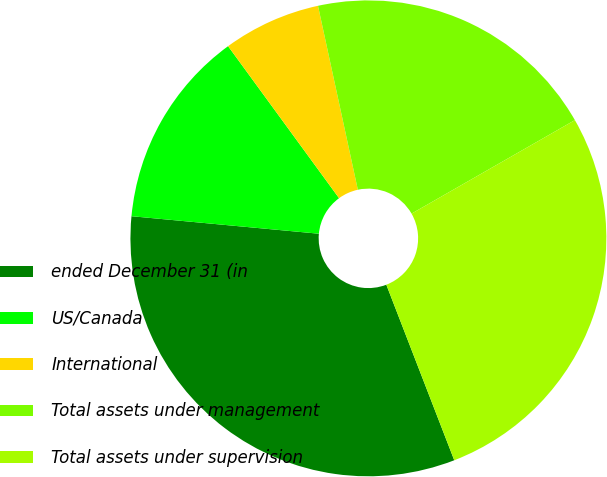<chart> <loc_0><loc_0><loc_500><loc_500><pie_chart><fcel>ended December 31 (in<fcel>US/Canada<fcel>International<fcel>Total assets under management<fcel>Total assets under supervision<nl><fcel>32.36%<fcel>13.48%<fcel>6.64%<fcel>20.12%<fcel>27.4%<nl></chart> 